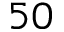Convert formula to latex. <formula><loc_0><loc_0><loc_500><loc_500>5 0</formula> 